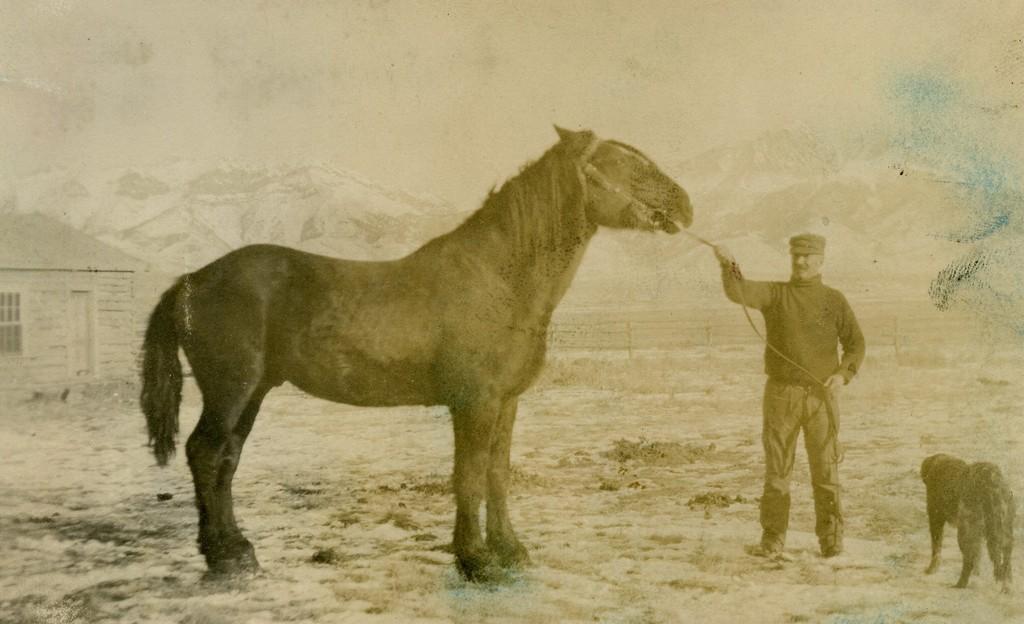In one or two sentences, can you explain what this image depicts? This is the picture of a person holding a horse and a dog in front of horse and a house. 